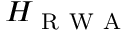Convert formula to latex. <formula><loc_0><loc_0><loc_500><loc_500>H _ { R W A }</formula> 